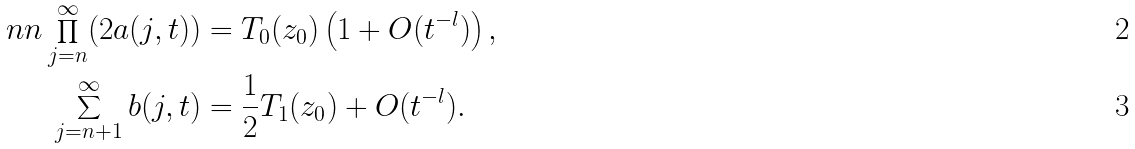<formula> <loc_0><loc_0><loc_500><loc_500>\ n n \prod _ { j = n } ^ { \infty } ( 2 a ( j , t ) ) & = T _ { 0 } ( z _ { 0 } ) \left ( 1 + O ( t ^ { - l } ) \right ) , \\ \sum _ { j = n + 1 } ^ { \infty } b ( j , t ) & = \frac { 1 } { 2 } T _ { 1 } ( z _ { 0 } ) + O ( t ^ { - l } ) .</formula> 